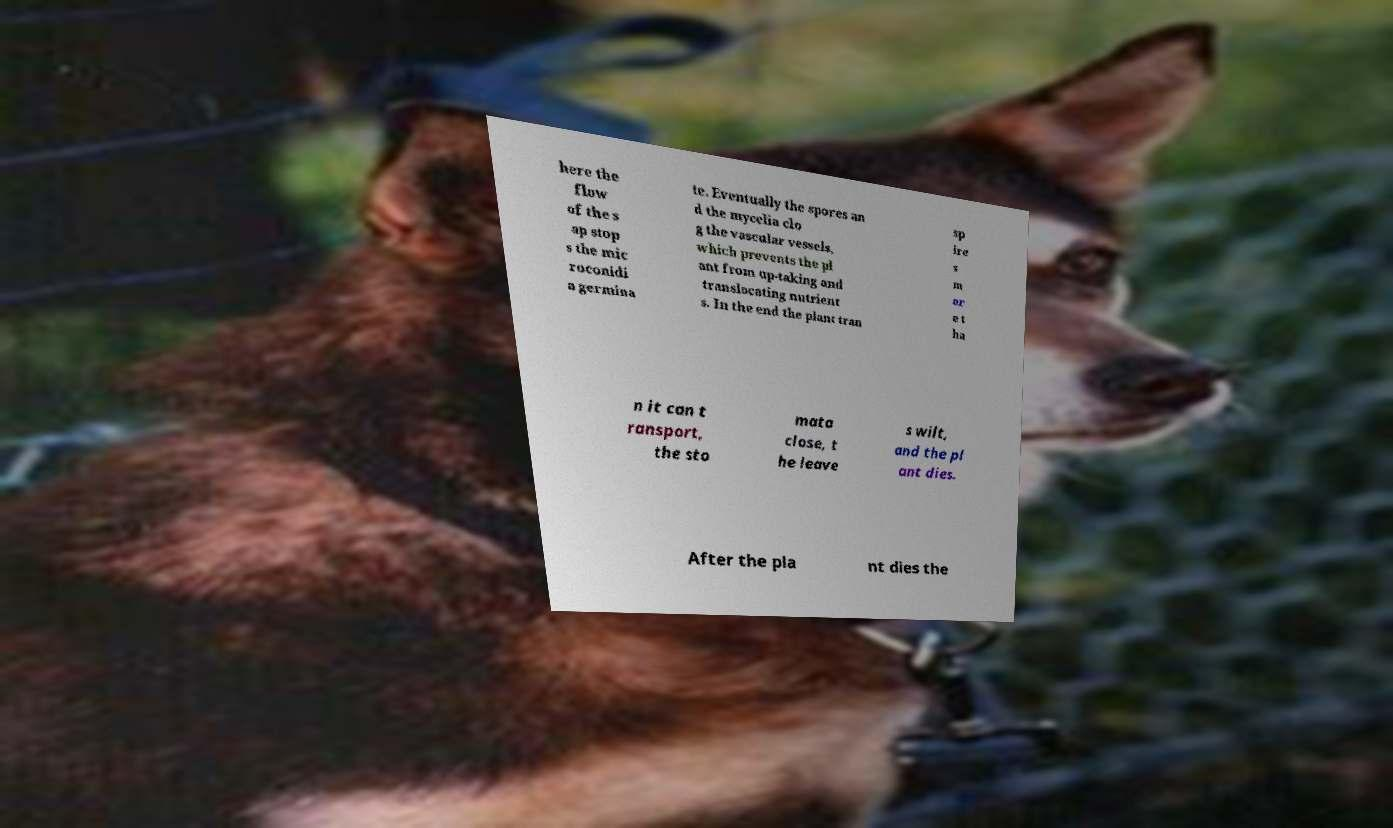Could you extract and type out the text from this image? here the flow of the s ap stop s the mic roconidi a germina te. Eventually the spores an d the mycelia clo g the vascular vessels, which prevents the pl ant from up-taking and translocating nutrient s. In the end the plant tran sp ire s m or e t ha n it can t ransport, the sto mata close, t he leave s wilt, and the pl ant dies. After the pla nt dies the 